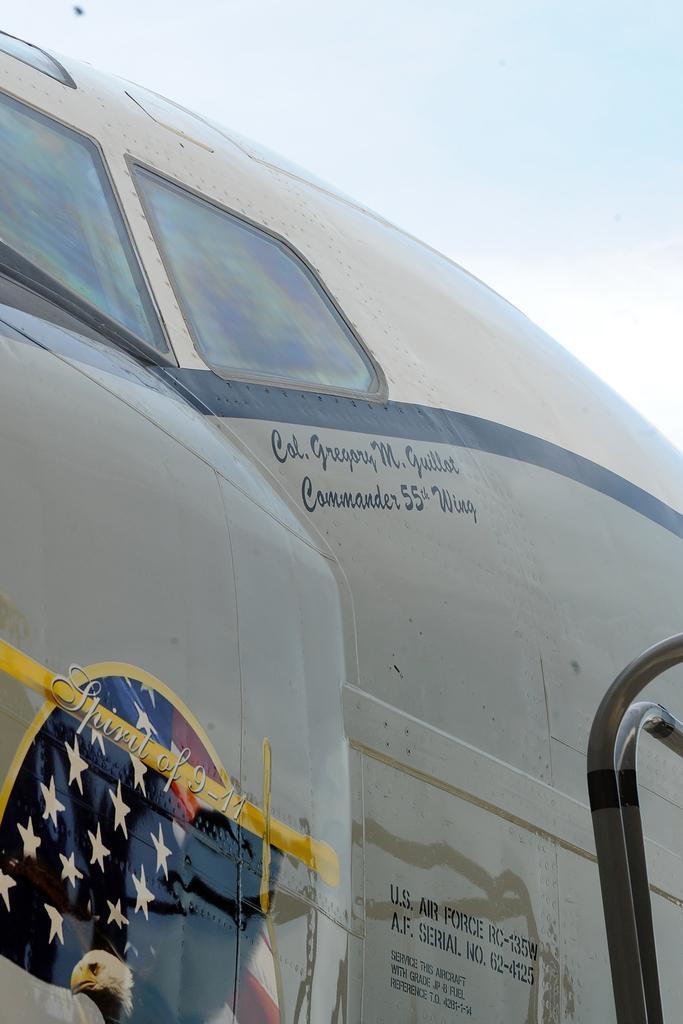How would you summarize this image in a sentence or two? It seems like a zoom-in picture of an airplane and the sky is in the background. 